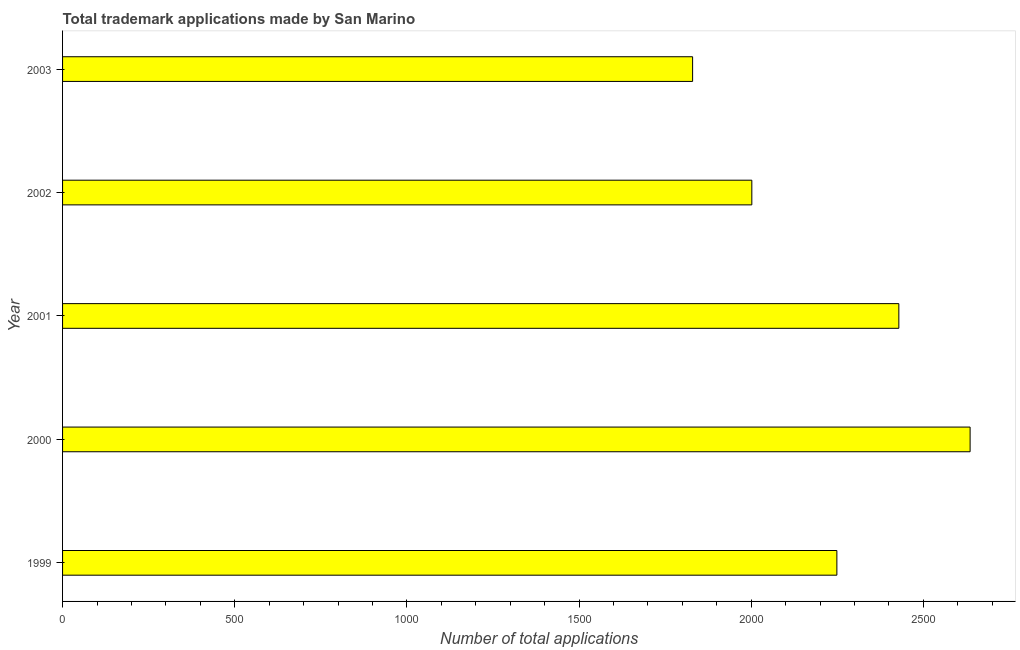Does the graph contain any zero values?
Keep it short and to the point. No. Does the graph contain grids?
Your answer should be compact. No. What is the title of the graph?
Ensure brevity in your answer.  Total trademark applications made by San Marino. What is the label or title of the X-axis?
Keep it short and to the point. Number of total applications. What is the label or title of the Y-axis?
Give a very brief answer. Year. What is the number of trademark applications in 2001?
Offer a very short reply. 2429. Across all years, what is the maximum number of trademark applications?
Provide a short and direct response. 2636. Across all years, what is the minimum number of trademark applications?
Offer a very short reply. 1830. In which year was the number of trademark applications maximum?
Provide a succinct answer. 2000. What is the sum of the number of trademark applications?
Ensure brevity in your answer.  1.11e+04. What is the difference between the number of trademark applications in 1999 and 2001?
Give a very brief answer. -180. What is the average number of trademark applications per year?
Keep it short and to the point. 2229. What is the median number of trademark applications?
Ensure brevity in your answer.  2249. In how many years, is the number of trademark applications greater than 2000 ?
Ensure brevity in your answer.  4. Do a majority of the years between 2003 and 2001 (inclusive) have number of trademark applications greater than 1600 ?
Offer a very short reply. Yes. What is the ratio of the number of trademark applications in 2001 to that in 2002?
Ensure brevity in your answer.  1.21. What is the difference between the highest and the second highest number of trademark applications?
Your answer should be compact. 207. What is the difference between the highest and the lowest number of trademark applications?
Your answer should be compact. 806. In how many years, is the number of trademark applications greater than the average number of trademark applications taken over all years?
Offer a very short reply. 3. How many bars are there?
Ensure brevity in your answer.  5. How many years are there in the graph?
Provide a succinct answer. 5. What is the difference between two consecutive major ticks on the X-axis?
Your answer should be very brief. 500. What is the Number of total applications in 1999?
Ensure brevity in your answer.  2249. What is the Number of total applications of 2000?
Make the answer very short. 2636. What is the Number of total applications in 2001?
Make the answer very short. 2429. What is the Number of total applications of 2002?
Provide a succinct answer. 2002. What is the Number of total applications of 2003?
Make the answer very short. 1830. What is the difference between the Number of total applications in 1999 and 2000?
Keep it short and to the point. -387. What is the difference between the Number of total applications in 1999 and 2001?
Give a very brief answer. -180. What is the difference between the Number of total applications in 1999 and 2002?
Offer a very short reply. 247. What is the difference between the Number of total applications in 1999 and 2003?
Offer a very short reply. 419. What is the difference between the Number of total applications in 2000 and 2001?
Keep it short and to the point. 207. What is the difference between the Number of total applications in 2000 and 2002?
Keep it short and to the point. 634. What is the difference between the Number of total applications in 2000 and 2003?
Provide a succinct answer. 806. What is the difference between the Number of total applications in 2001 and 2002?
Give a very brief answer. 427. What is the difference between the Number of total applications in 2001 and 2003?
Make the answer very short. 599. What is the difference between the Number of total applications in 2002 and 2003?
Keep it short and to the point. 172. What is the ratio of the Number of total applications in 1999 to that in 2000?
Your answer should be compact. 0.85. What is the ratio of the Number of total applications in 1999 to that in 2001?
Your answer should be very brief. 0.93. What is the ratio of the Number of total applications in 1999 to that in 2002?
Provide a short and direct response. 1.12. What is the ratio of the Number of total applications in 1999 to that in 2003?
Your answer should be compact. 1.23. What is the ratio of the Number of total applications in 2000 to that in 2001?
Your response must be concise. 1.08. What is the ratio of the Number of total applications in 2000 to that in 2002?
Keep it short and to the point. 1.32. What is the ratio of the Number of total applications in 2000 to that in 2003?
Your response must be concise. 1.44. What is the ratio of the Number of total applications in 2001 to that in 2002?
Provide a succinct answer. 1.21. What is the ratio of the Number of total applications in 2001 to that in 2003?
Give a very brief answer. 1.33. What is the ratio of the Number of total applications in 2002 to that in 2003?
Ensure brevity in your answer.  1.09. 